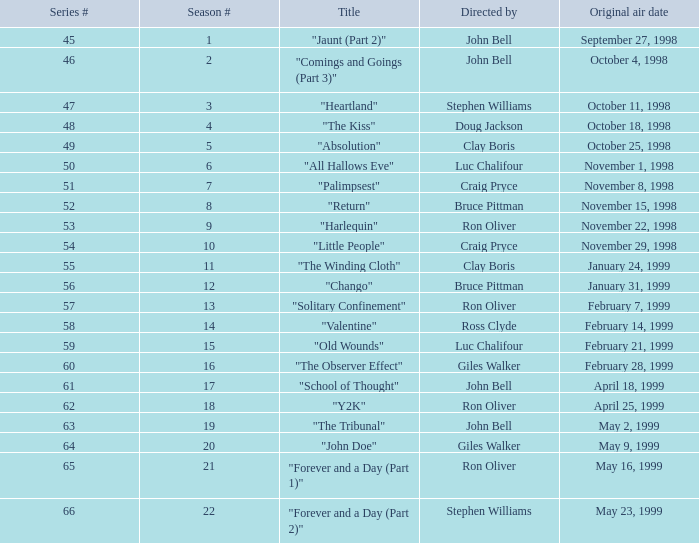In which season, titled "jaunt (part 2)", does the series number exceed 45? None. 